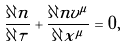<formula> <loc_0><loc_0><loc_500><loc_500>\frac { \partial n } { \partial \tau } + \frac { \partial n v ^ { \mu } } { \partial x ^ { \mu } } = 0 ,</formula> 